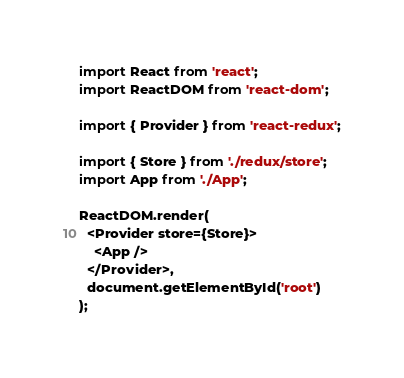Convert code to text. <code><loc_0><loc_0><loc_500><loc_500><_JavaScript_>import React from 'react';
import ReactDOM from 'react-dom';

import { Provider } from 'react-redux';

import { Store } from './redux/store';
import App from './App';

ReactDOM.render(
  <Provider store={Store}>
    <App />
  </Provider>,
  document.getElementById('root')
);
</code> 